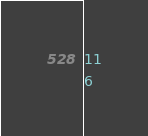<code> <loc_0><loc_0><loc_500><loc_500><_SQL_>11
6</code> 